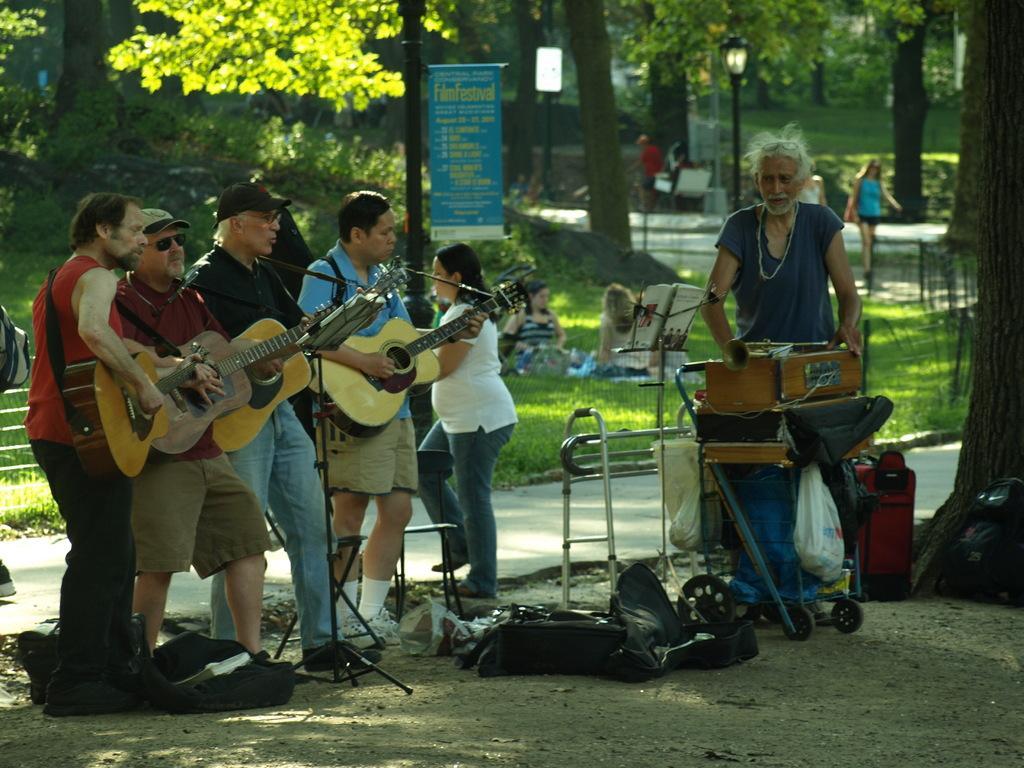In one or two sentences, can you explain what this image depicts? In this image there are four people who are playing the guitar and there is a mic in front of them. There is a man beside them who is standing near the trumpet. At the background there is banner,grass and trees. In the grass there are two women who are sitting with a bag beside them. There is a pole at the back side. 